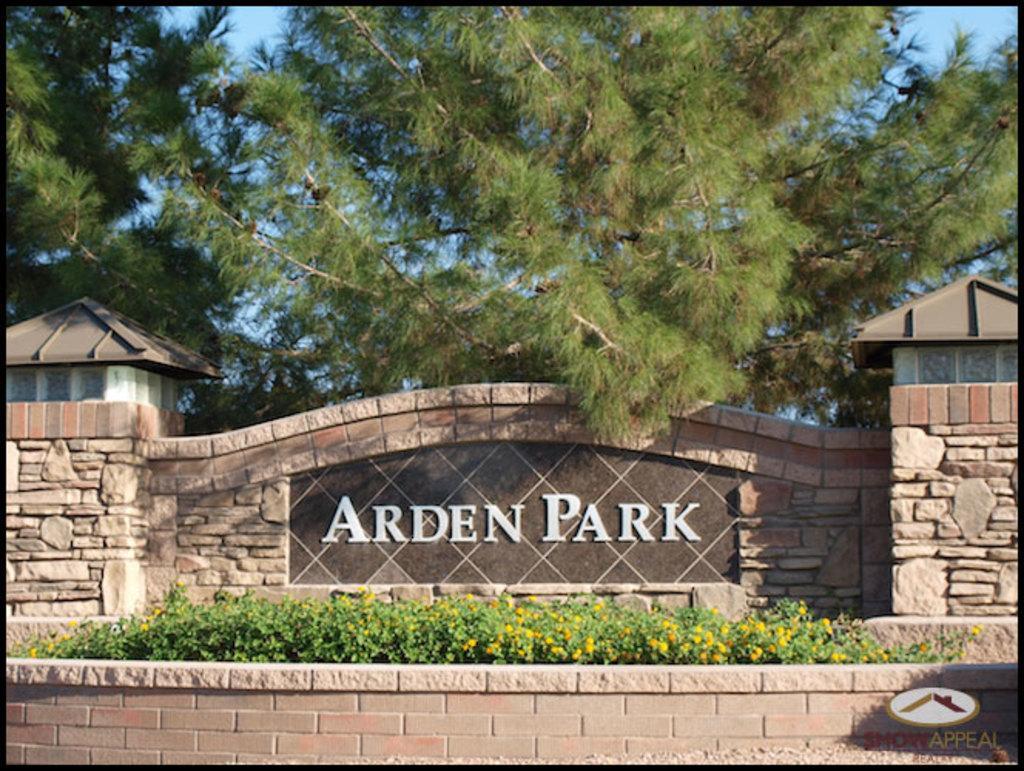How would you summarize this image in a sentence or two? In this image we can see a wall with text and sheds on both side, in front of the wall there are plants with flower and there are trees and sky in the background. 